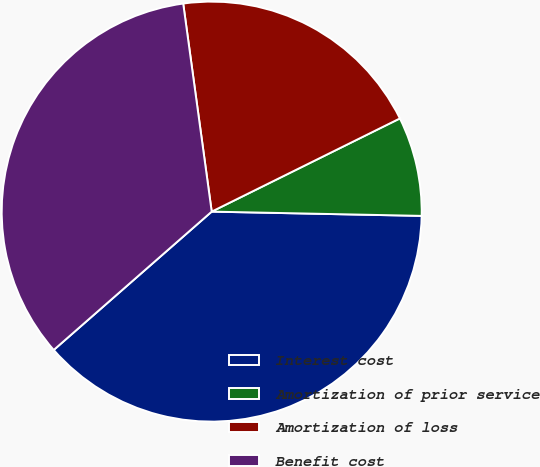<chart> <loc_0><loc_0><loc_500><loc_500><pie_chart><fcel>Interest cost<fcel>Amortization of prior service<fcel>Amortization of loss<fcel>Benefit cost<nl><fcel>38.23%<fcel>7.64%<fcel>19.85%<fcel>34.28%<nl></chart> 